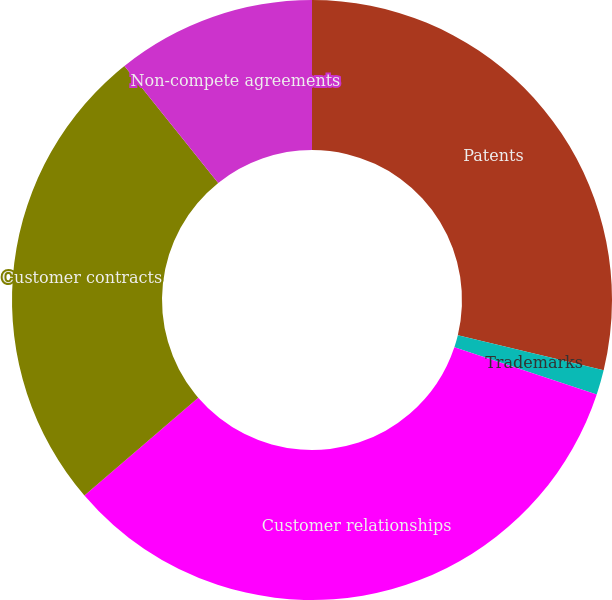Convert chart to OTSL. <chart><loc_0><loc_0><loc_500><loc_500><pie_chart><fcel>Patents<fcel>Trademarks<fcel>Customer relationships<fcel>Customer contracts<fcel>Non-compete agreements<nl><fcel>28.76%<fcel>1.34%<fcel>33.6%<fcel>25.54%<fcel>10.75%<nl></chart> 